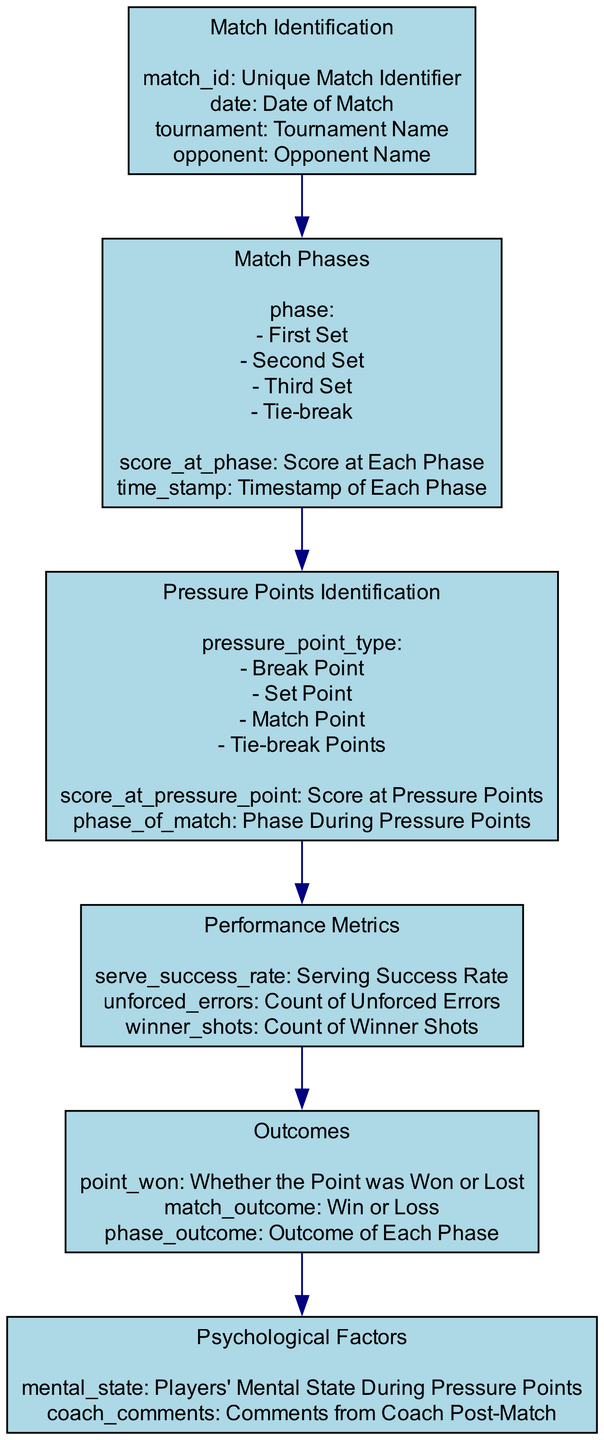What is the first block in the diagram? The first block listed in the diagram is "Match Identification," which is where the analysis begins, focusing on identifying the match details.
Answer: Match Identification How many match phases are identified in the diagram? The diagram outlines four match phases: First Set, Second Set, Third Set, and Tie-break. Counting these gives a total of four phases.
Answer: 4 What performance metric is related to serving? The performance metric related to serving is "serve_success_rate," as it focuses specifically on the success of serving during the match.
Answer: serve_success_rate What type of pressure point occurs at the end of a match? The type of pressure point that occurs at the end of a match is "Match Point," which is crucial for determining the outcome of the match.
Answer: Match Point Which block follows the "Pressure Points Identification" block? The block that follows "Pressure Points Identification" is "Performance Metrics," indicating an analysis that considers the player's performance in the context of pressure points.
Answer: Performance Metrics What psychological factor is assessed during pressure points? The psychological factor assessed during pressure points is "mental_state," focusing on the player's emotional and psychological condition during critical moments.
Answer: mental_state How does the "Outcomes" block relate to the "Performance Metrics" block? The "Outcomes" block is directly influenced by the information provided in the "Performance Metrics" block, suggesting that performance metrics can affect the match outcomes.
Answer: Directly What is evaluated alongside performance metrics in the diagram? "Psychological Factors" are evaluated alongside the performance metrics, indicating the importance of mental aspects in match performance.
Answer: Psychological Factors Which element contains information about the opponent? The element that contains information about the opponent is "Match Identification," which includes details pertaining to the opponent faced during the match.
Answer: Match Identification 